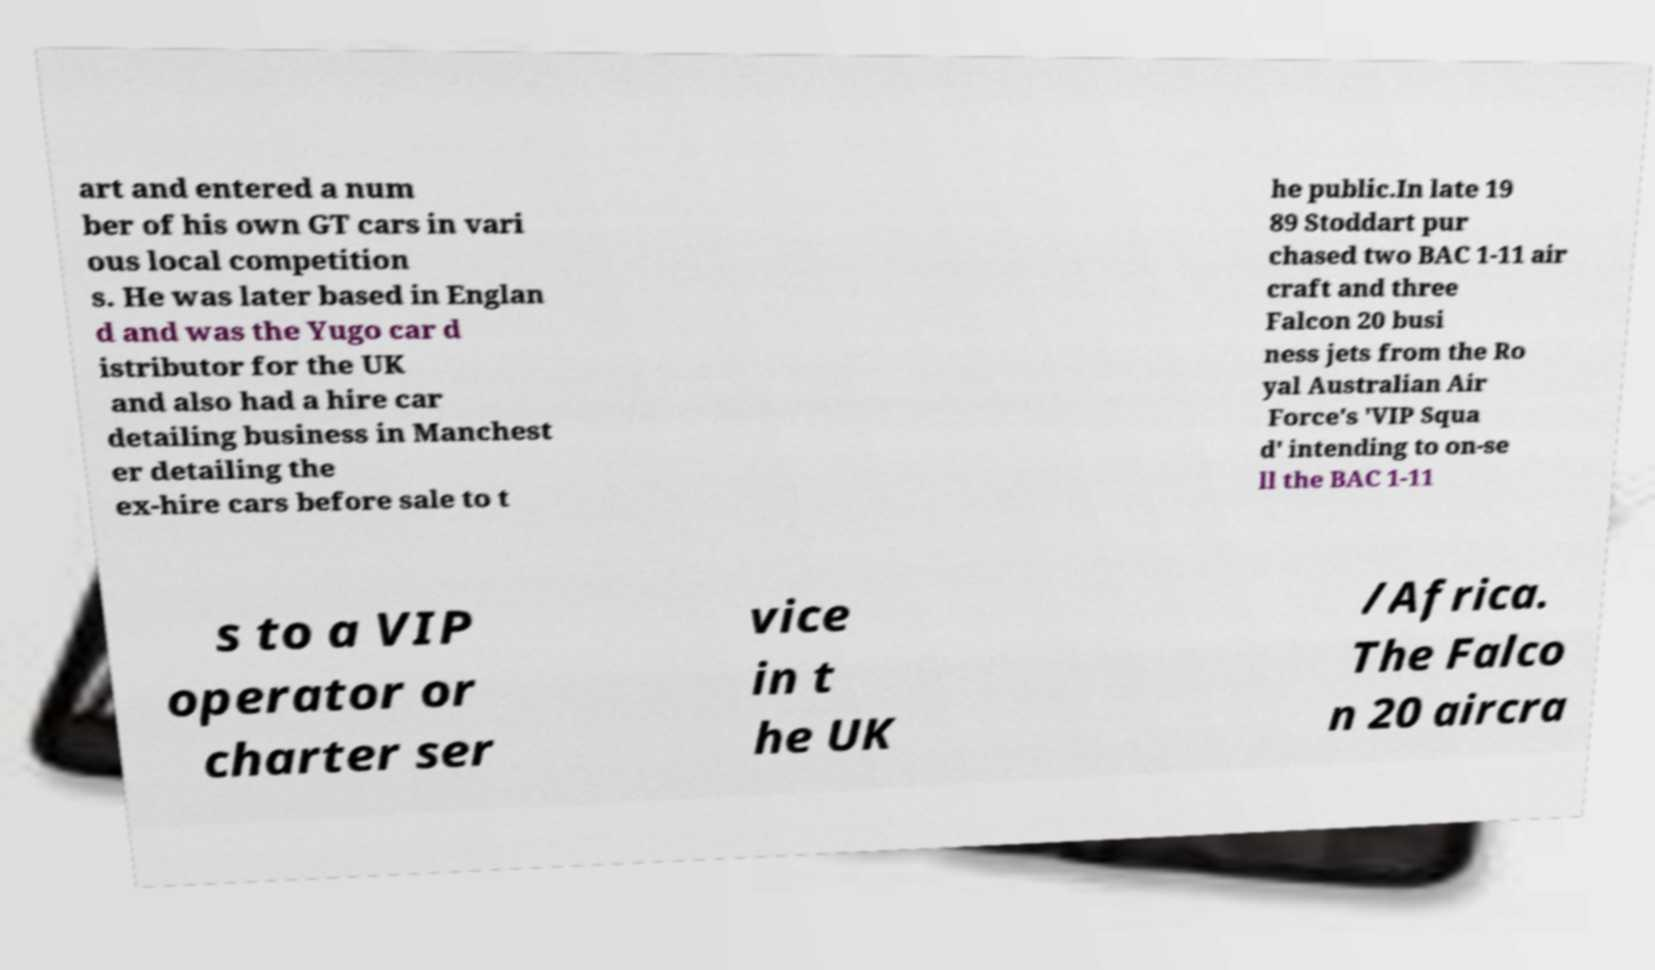Could you assist in decoding the text presented in this image and type it out clearly? art and entered a num ber of his own GT cars in vari ous local competition s. He was later based in Englan d and was the Yugo car d istributor for the UK and also had a hire car detailing business in Manchest er detailing the ex-hire cars before sale to t he public.In late 19 89 Stoddart pur chased two BAC 1-11 air craft and three Falcon 20 busi ness jets from the Ro yal Australian Air Force's 'VIP Squa d' intending to on-se ll the BAC 1-11 s to a VIP operator or charter ser vice in t he UK /Africa. The Falco n 20 aircra 